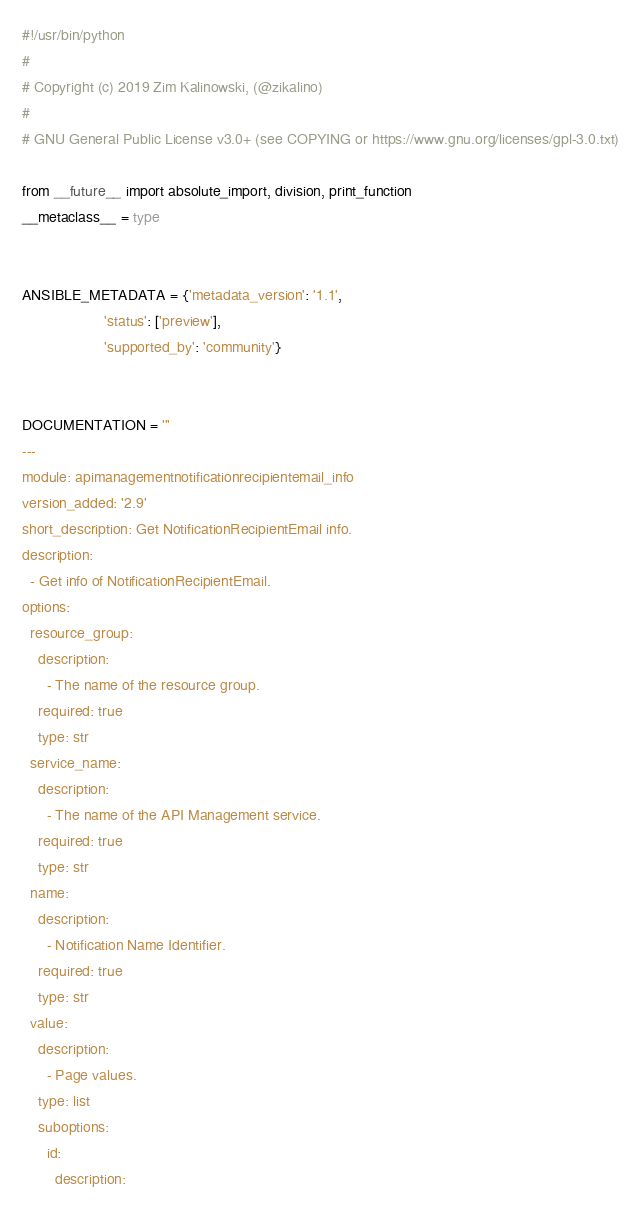<code> <loc_0><loc_0><loc_500><loc_500><_Python_>#!/usr/bin/python
#
# Copyright (c) 2019 Zim Kalinowski, (@zikalino)
#
# GNU General Public License v3.0+ (see COPYING or https://www.gnu.org/licenses/gpl-3.0.txt)

from __future__ import absolute_import, division, print_function
__metaclass__ = type


ANSIBLE_METADATA = {'metadata_version': '1.1',
                    'status': ['preview'],
                    'supported_by': 'community'}


DOCUMENTATION = '''
---
module: apimanagementnotificationrecipientemail_info
version_added: '2.9'
short_description: Get NotificationRecipientEmail info.
description:
  - Get info of NotificationRecipientEmail.
options:
  resource_group:
    description:
      - The name of the resource group.
    required: true
    type: str
  service_name:
    description:
      - The name of the API Management service.
    required: true
    type: str
  name:
    description:
      - Notification Name Identifier.
    required: true
    type: str
  value:
    description:
      - Page values.
    type: list
    suboptions:
      id:
        description:</code> 